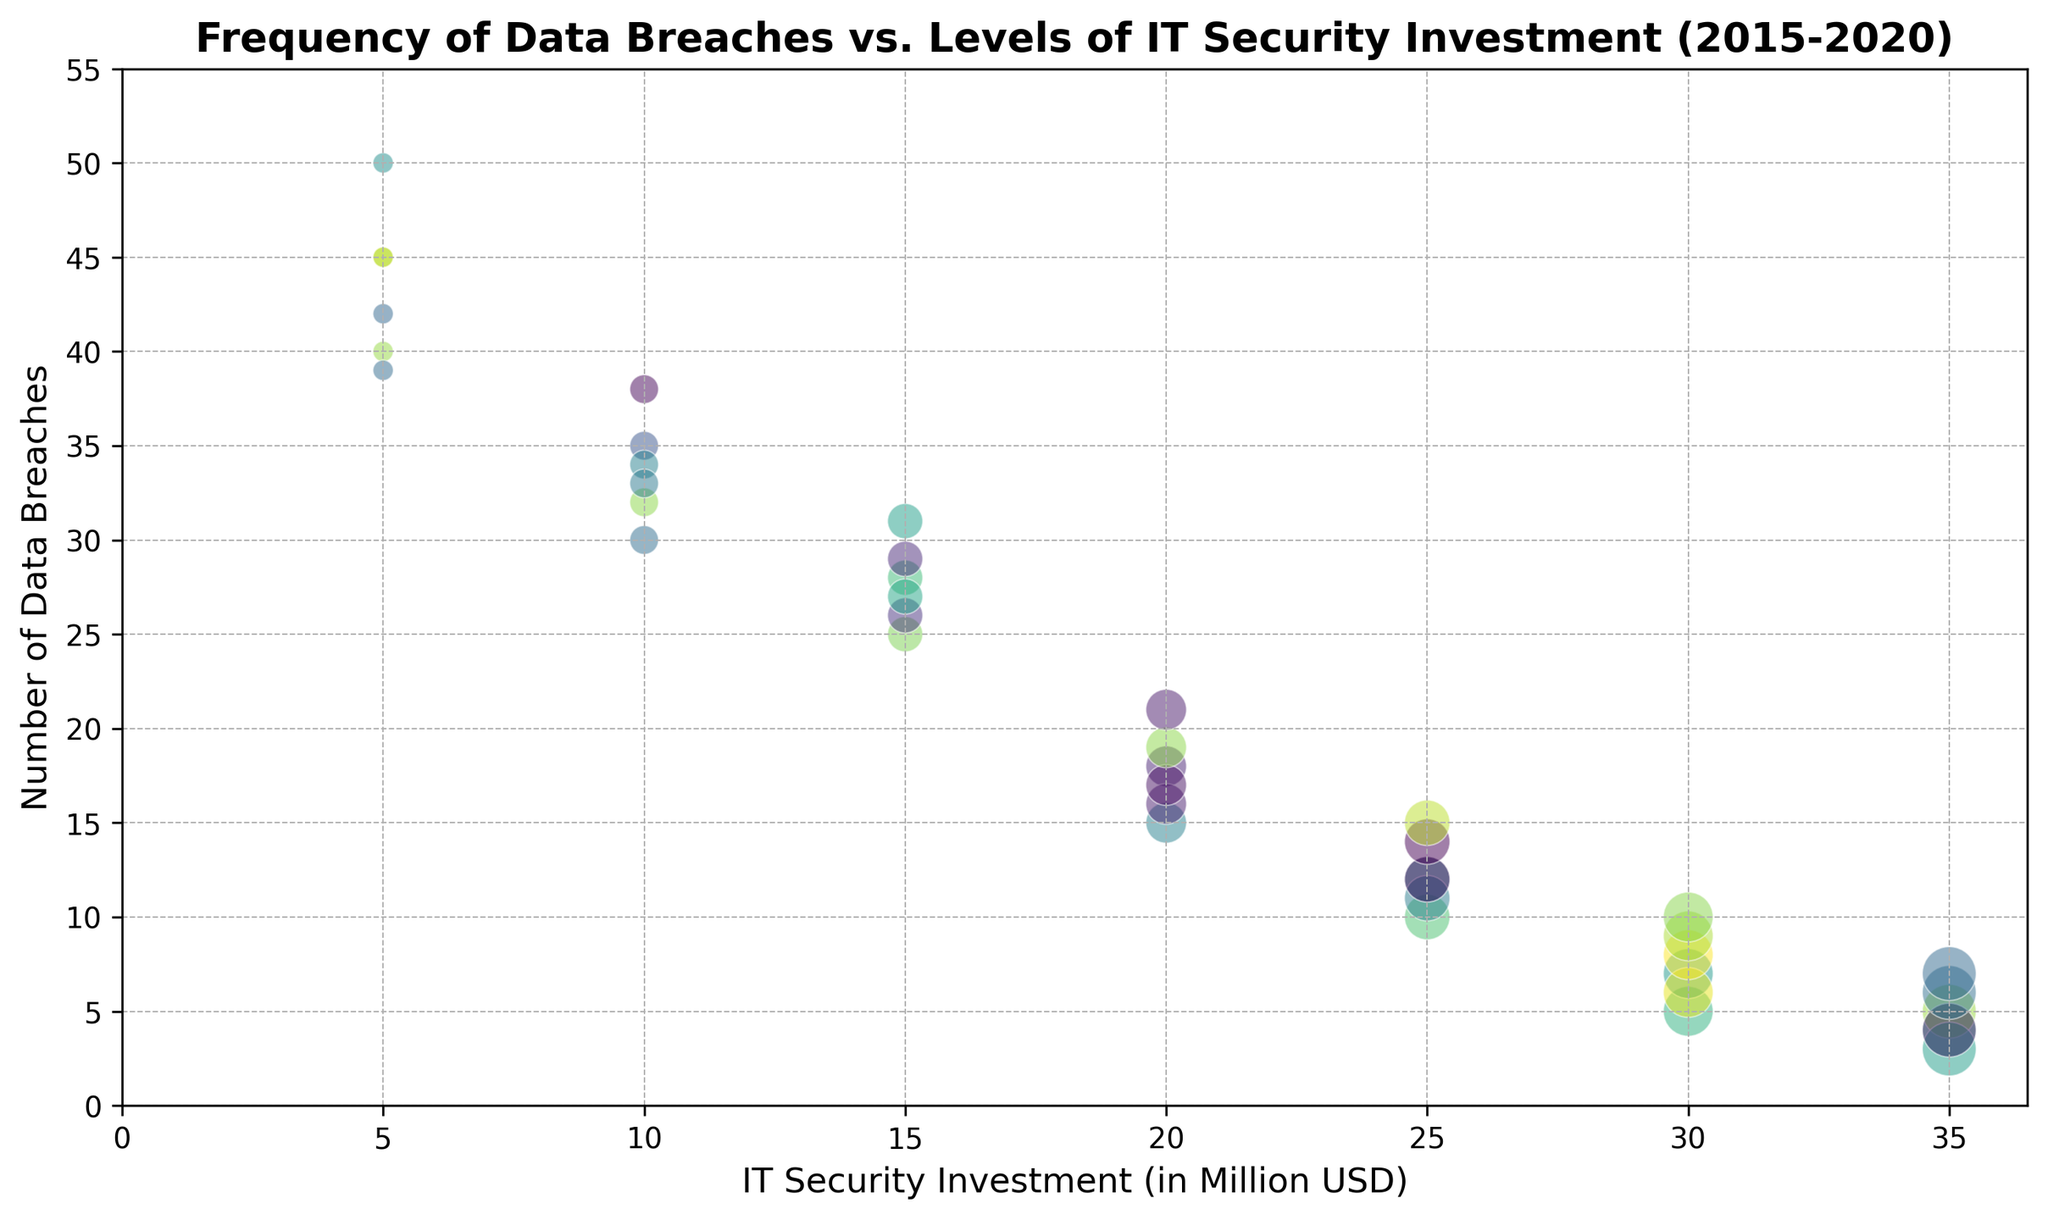Which year has the highest number of data breaches with an IT security investment of 5 million USD? Look at the data points where IT security investment is 5 million USD. The highest number of breaches corresponds to the point in 2016 with 50 breaches.
Answer: 2016 Is there any year where the investment of 35 million USD corresponds to more data breaches than the investment of 30 million USD? Compare the data breach numbers for 35 million USD and 30 million USD investment across the years from 2015 to 2020. For each year, the number of breaches for 35 million is always less than that for 30 million.
Answer: No Which IT security investment saw the sharpest decrease in data breaches in 2017 compared to the previous year? Compare the number of breaches for each investment amount from 2016 to 2017. The investment of 5 million USD saw the biggest drop, from 50 in 2016 to 40 in 2017, a decrease of 10 breaches.
Answer: 5 million USD How does the number of data breaches for 10 million USD of IT security investment in 2020 compare to 2019? Look at the data points for 2020 and 2019 with 10 million USD investment. The number of breaches decreased from 33 in 2019 to 38 in 2020.
Answer: Increased What is the average number of data breaches for 25 million USD security investments across all years? Add the number of data breaches for 25 million USD across the years (10, 12, 11, 12, 14, 15) and divide by 6. The total is 74, so the average is 74/6 = 12.33.
Answer: 12.33 For a 20 million USD investment, which year shows the greatest number of data breaches? Review the data points for each year with a 20 million USD investment. The highest number is in 2020 with 21 data breaches.
Answer: 2020 Compare the number of data breaches for 30 million USD IT security investment in the years 2015 and 2018. 2015 has 5 breaches and 2018 has 8 breaches for the 30 million USD investment, so 2018 has more.
Answer: 2018 What is the trend in the number of data breaches for 15 million USD investment from 2015 to 2020? Look at the number of breaches each year for a 15 million USD investment: 25 (2015), 28 (2016), 26 (2017), 27 (2018), 29 (2019), and 31 (2020). There's an increasing trend overall.
Answer: Increasing What is the most frequent data breach count for 35 million USD investment from 2015 to 2020? Check the data points corresponding to 35 million USD investment: 4, 5, 3, 4, 6, 7. The most frequently occurring count is 4.
Answer: 4 In which year did the data breach frequency for a 20 million USD investment decrease the most compared to the previous year? Compare the differences in breach counts for 20 million USD investment year by year. The biggest drop is from 2015 to 2016, decreasing by 15 (30 - 15).
Answer: 2016 